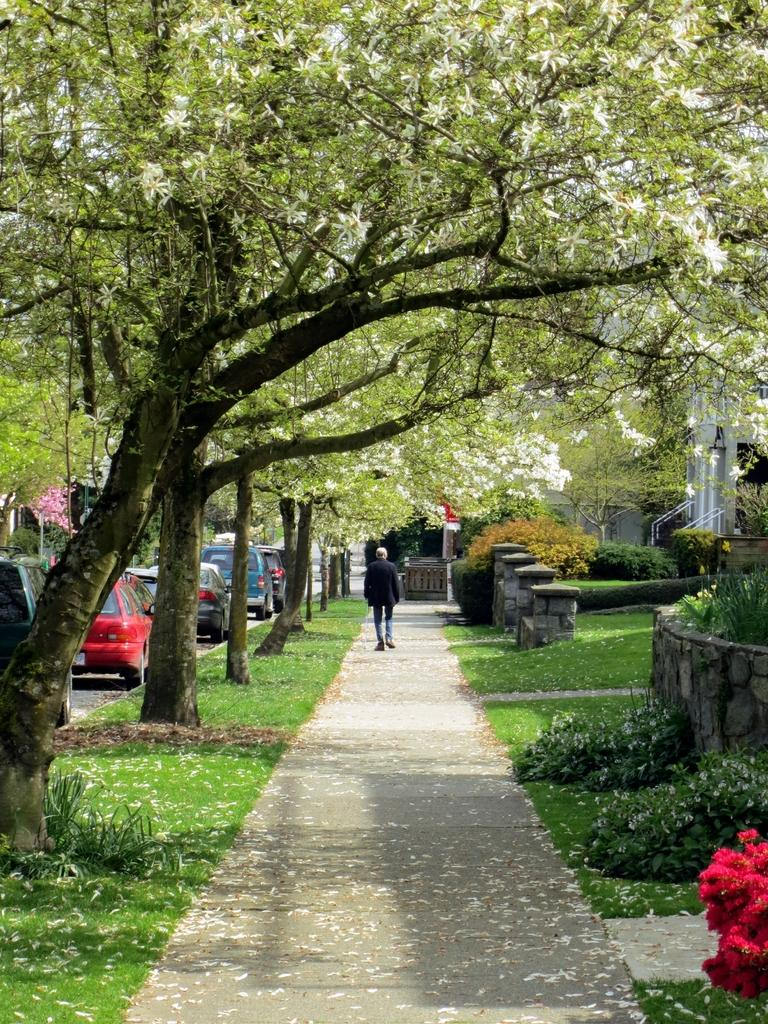What type of vegetation can be seen on either side of the road in the image? There is grass, plants, and trees on either side of the road in the image. What is present on the left side of the picture? There are vehicles on the left side of the picture. Can you describe the person walking on the road? A man is walking on the road. Where is the nest of the sheep located in the image? There is no nest or sheep present in the image. What type of pan is being used by the man walking on the road? There is no pan visible in the image, and the man walking on the road is not using any pan. 